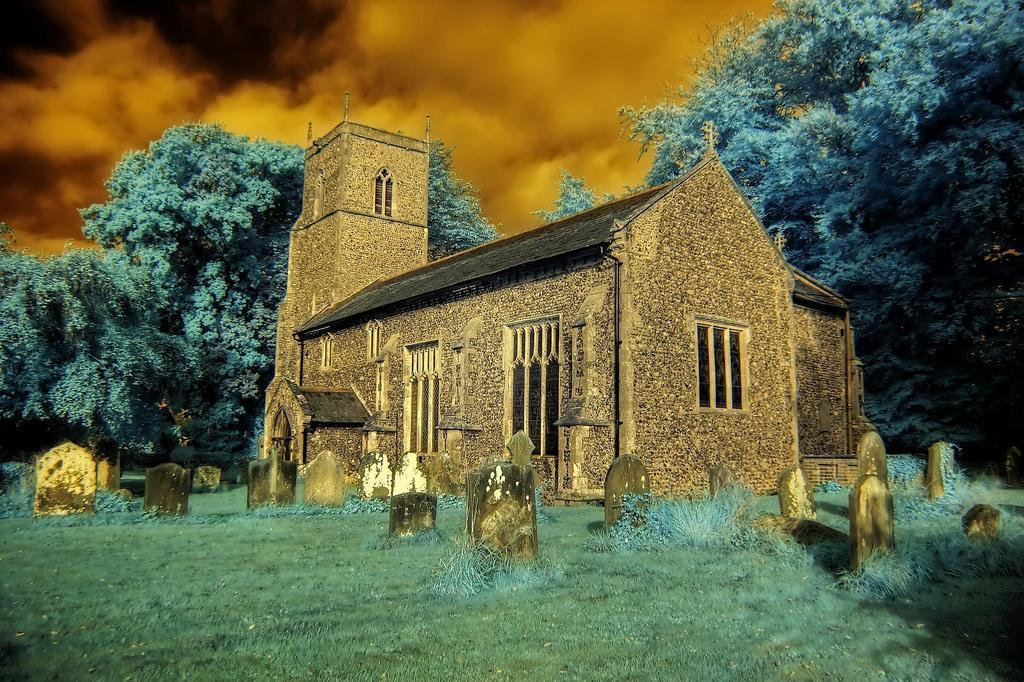What type of image is this? The image appears to be an edited image. What can be seen in the foreground of the image? There are many graves on the grass in the image. What is located in the background of the image? There are trees visible in the background of the image. Can you describe the building in the image? There is a building in the image, but no specific details about its architecture or purpose are provided. What type of chess pieces can be seen on the grass in the image? There are no chess pieces visible in the image; it features graves on the grass. What type of amusement park rides can be seen in the background of the image? There are no amusement park rides visible in the image; it features trees in the background. 